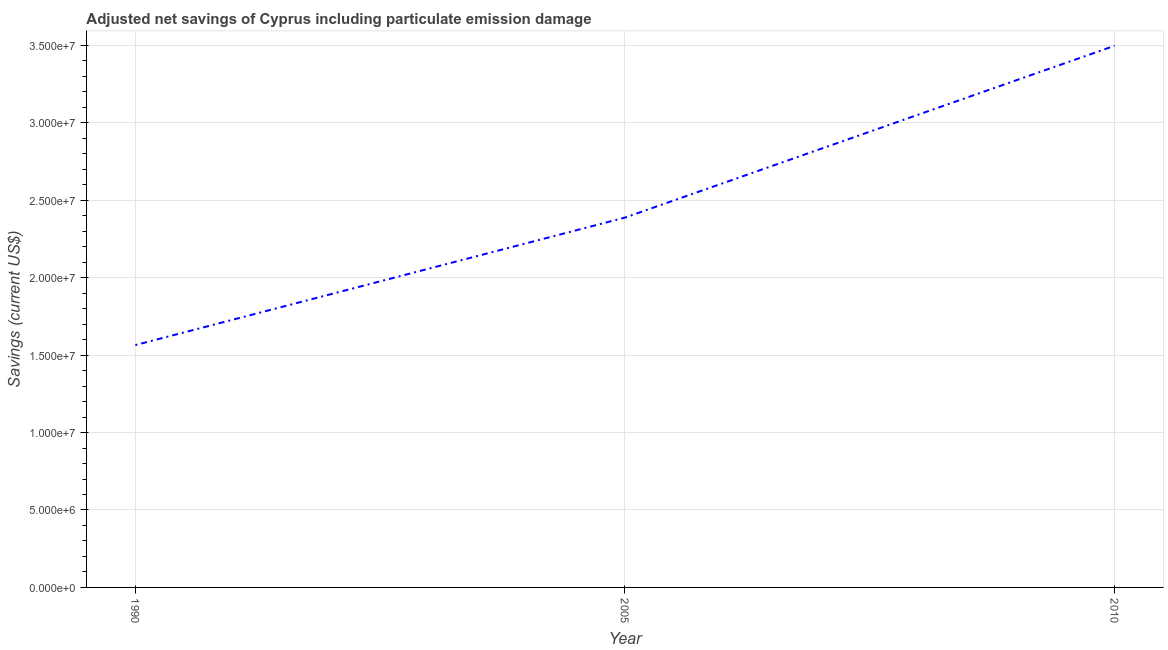What is the adjusted net savings in 2005?
Ensure brevity in your answer.  2.39e+07. Across all years, what is the maximum adjusted net savings?
Give a very brief answer. 3.50e+07. Across all years, what is the minimum adjusted net savings?
Make the answer very short. 1.57e+07. In which year was the adjusted net savings maximum?
Your answer should be compact. 2010. In which year was the adjusted net savings minimum?
Offer a terse response. 1990. What is the sum of the adjusted net savings?
Your answer should be compact. 7.45e+07. What is the difference between the adjusted net savings in 1990 and 2010?
Provide a short and direct response. -1.93e+07. What is the average adjusted net savings per year?
Give a very brief answer. 2.48e+07. What is the median adjusted net savings?
Your answer should be very brief. 2.39e+07. In how many years, is the adjusted net savings greater than 5000000 US$?
Keep it short and to the point. 3. What is the ratio of the adjusted net savings in 1990 to that in 2010?
Ensure brevity in your answer.  0.45. What is the difference between the highest and the second highest adjusted net savings?
Make the answer very short. 1.11e+07. What is the difference between the highest and the lowest adjusted net savings?
Give a very brief answer. 1.93e+07. How many years are there in the graph?
Give a very brief answer. 3. Are the values on the major ticks of Y-axis written in scientific E-notation?
Make the answer very short. Yes. Does the graph contain any zero values?
Offer a very short reply. No. What is the title of the graph?
Keep it short and to the point. Adjusted net savings of Cyprus including particulate emission damage. What is the label or title of the X-axis?
Offer a very short reply. Year. What is the label or title of the Y-axis?
Keep it short and to the point. Savings (current US$). What is the Savings (current US$) in 1990?
Your answer should be compact. 1.57e+07. What is the Savings (current US$) of 2005?
Offer a terse response. 2.39e+07. What is the Savings (current US$) of 2010?
Your answer should be compact. 3.50e+07. What is the difference between the Savings (current US$) in 1990 and 2005?
Offer a terse response. -8.23e+06. What is the difference between the Savings (current US$) in 1990 and 2010?
Your response must be concise. -1.93e+07. What is the difference between the Savings (current US$) in 2005 and 2010?
Your answer should be very brief. -1.11e+07. What is the ratio of the Savings (current US$) in 1990 to that in 2005?
Keep it short and to the point. 0.66. What is the ratio of the Savings (current US$) in 1990 to that in 2010?
Provide a succinct answer. 0.45. What is the ratio of the Savings (current US$) in 2005 to that in 2010?
Your answer should be compact. 0.68. 